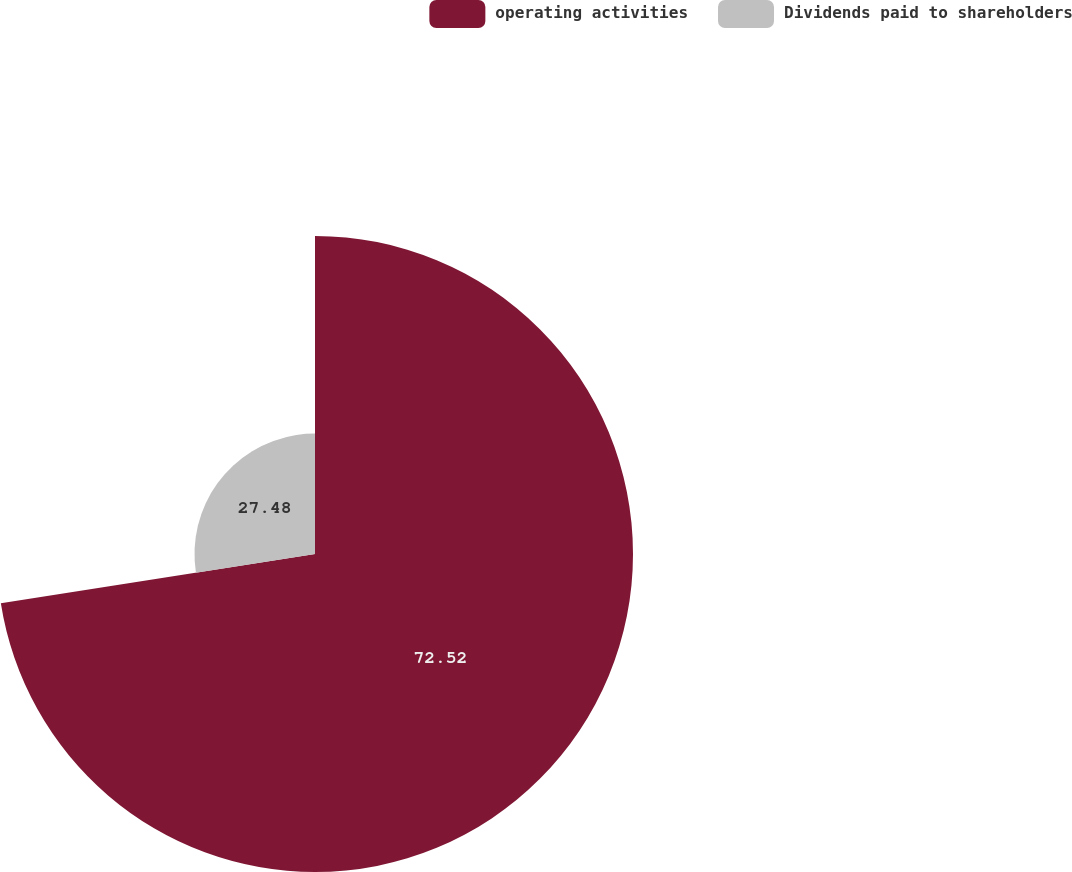Convert chart to OTSL. <chart><loc_0><loc_0><loc_500><loc_500><pie_chart><fcel>operating activities<fcel>Dividends paid to shareholders<nl><fcel>72.52%<fcel>27.48%<nl></chart> 